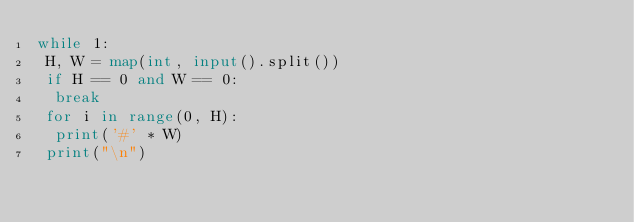Convert code to text. <code><loc_0><loc_0><loc_500><loc_500><_Python_>while 1:
 H, W = map(int, input().split())
 if H == 0 and W == 0:
  break
 for i in range(0, H):
  print('#' * W)
 print("\n")</code> 